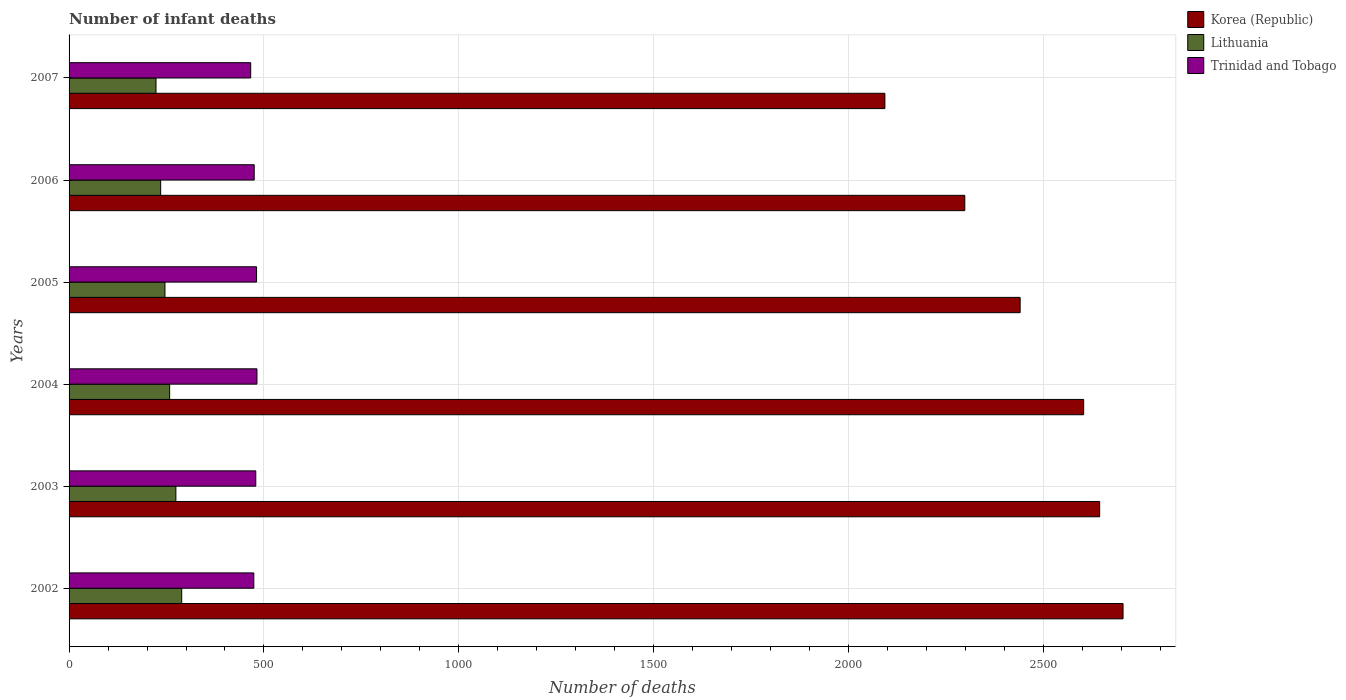How many groups of bars are there?
Your answer should be compact. 6. Are the number of bars on each tick of the Y-axis equal?
Ensure brevity in your answer.  Yes. How many bars are there on the 5th tick from the bottom?
Offer a very short reply. 3. In how many cases, is the number of bars for a given year not equal to the number of legend labels?
Offer a terse response. 0. What is the number of infant deaths in Lithuania in 2002?
Your answer should be compact. 289. Across all years, what is the maximum number of infant deaths in Trinidad and Tobago?
Offer a very short reply. 482. Across all years, what is the minimum number of infant deaths in Korea (Republic)?
Your answer should be very brief. 2093. What is the total number of infant deaths in Lithuania in the graph?
Your answer should be compact. 1525. What is the difference between the number of infant deaths in Lithuania in 2002 and that in 2005?
Give a very brief answer. 43. What is the difference between the number of infant deaths in Korea (Republic) in 2006 and the number of infant deaths in Trinidad and Tobago in 2002?
Ensure brevity in your answer.  1824. What is the average number of infant deaths in Trinidad and Tobago per year?
Provide a short and direct response. 476.17. In the year 2003, what is the difference between the number of infant deaths in Lithuania and number of infant deaths in Trinidad and Tobago?
Ensure brevity in your answer.  -205. In how many years, is the number of infant deaths in Trinidad and Tobago greater than 100 ?
Give a very brief answer. 6. What is the ratio of the number of infant deaths in Korea (Republic) in 2002 to that in 2004?
Make the answer very short. 1.04. What is the difference between the highest and the lowest number of infant deaths in Korea (Republic)?
Keep it short and to the point. 611. In how many years, is the number of infant deaths in Trinidad and Tobago greater than the average number of infant deaths in Trinidad and Tobago taken over all years?
Give a very brief answer. 3. What does the 2nd bar from the bottom in 2006 represents?
Your answer should be very brief. Lithuania. Is it the case that in every year, the sum of the number of infant deaths in Lithuania and number of infant deaths in Korea (Republic) is greater than the number of infant deaths in Trinidad and Tobago?
Provide a short and direct response. Yes. How many bars are there?
Provide a short and direct response. 18. Are all the bars in the graph horizontal?
Make the answer very short. Yes. What is the difference between two consecutive major ticks on the X-axis?
Provide a succinct answer. 500. Does the graph contain any zero values?
Offer a very short reply. No. How are the legend labels stacked?
Ensure brevity in your answer.  Vertical. What is the title of the graph?
Offer a terse response. Number of infant deaths. What is the label or title of the X-axis?
Your answer should be compact. Number of deaths. What is the Number of deaths of Korea (Republic) in 2002?
Provide a short and direct response. 2704. What is the Number of deaths in Lithuania in 2002?
Your response must be concise. 289. What is the Number of deaths of Trinidad and Tobago in 2002?
Keep it short and to the point. 474. What is the Number of deaths of Korea (Republic) in 2003?
Offer a very short reply. 2644. What is the Number of deaths of Lithuania in 2003?
Offer a terse response. 274. What is the Number of deaths in Trinidad and Tobago in 2003?
Ensure brevity in your answer.  479. What is the Number of deaths in Korea (Republic) in 2004?
Your answer should be compact. 2603. What is the Number of deaths of Lithuania in 2004?
Keep it short and to the point. 258. What is the Number of deaths in Trinidad and Tobago in 2004?
Your answer should be compact. 482. What is the Number of deaths in Korea (Republic) in 2005?
Make the answer very short. 2440. What is the Number of deaths of Lithuania in 2005?
Offer a terse response. 246. What is the Number of deaths in Trinidad and Tobago in 2005?
Offer a terse response. 481. What is the Number of deaths of Korea (Republic) in 2006?
Make the answer very short. 2298. What is the Number of deaths of Lithuania in 2006?
Provide a short and direct response. 235. What is the Number of deaths of Trinidad and Tobago in 2006?
Offer a terse response. 475. What is the Number of deaths in Korea (Republic) in 2007?
Provide a succinct answer. 2093. What is the Number of deaths in Lithuania in 2007?
Give a very brief answer. 223. What is the Number of deaths of Trinidad and Tobago in 2007?
Provide a short and direct response. 466. Across all years, what is the maximum Number of deaths in Korea (Republic)?
Make the answer very short. 2704. Across all years, what is the maximum Number of deaths of Lithuania?
Make the answer very short. 289. Across all years, what is the maximum Number of deaths of Trinidad and Tobago?
Offer a very short reply. 482. Across all years, what is the minimum Number of deaths in Korea (Republic)?
Your answer should be compact. 2093. Across all years, what is the minimum Number of deaths of Lithuania?
Your response must be concise. 223. Across all years, what is the minimum Number of deaths of Trinidad and Tobago?
Your response must be concise. 466. What is the total Number of deaths of Korea (Republic) in the graph?
Your answer should be compact. 1.48e+04. What is the total Number of deaths in Lithuania in the graph?
Your answer should be very brief. 1525. What is the total Number of deaths in Trinidad and Tobago in the graph?
Ensure brevity in your answer.  2857. What is the difference between the Number of deaths in Korea (Republic) in 2002 and that in 2003?
Ensure brevity in your answer.  60. What is the difference between the Number of deaths of Korea (Republic) in 2002 and that in 2004?
Offer a terse response. 101. What is the difference between the Number of deaths of Trinidad and Tobago in 2002 and that in 2004?
Offer a very short reply. -8. What is the difference between the Number of deaths of Korea (Republic) in 2002 and that in 2005?
Your response must be concise. 264. What is the difference between the Number of deaths of Lithuania in 2002 and that in 2005?
Give a very brief answer. 43. What is the difference between the Number of deaths in Trinidad and Tobago in 2002 and that in 2005?
Your response must be concise. -7. What is the difference between the Number of deaths of Korea (Republic) in 2002 and that in 2006?
Provide a succinct answer. 406. What is the difference between the Number of deaths of Lithuania in 2002 and that in 2006?
Ensure brevity in your answer.  54. What is the difference between the Number of deaths in Trinidad and Tobago in 2002 and that in 2006?
Your answer should be compact. -1. What is the difference between the Number of deaths in Korea (Republic) in 2002 and that in 2007?
Your response must be concise. 611. What is the difference between the Number of deaths of Lithuania in 2002 and that in 2007?
Offer a terse response. 66. What is the difference between the Number of deaths in Trinidad and Tobago in 2002 and that in 2007?
Your answer should be compact. 8. What is the difference between the Number of deaths of Lithuania in 2003 and that in 2004?
Offer a terse response. 16. What is the difference between the Number of deaths in Trinidad and Tobago in 2003 and that in 2004?
Your answer should be compact. -3. What is the difference between the Number of deaths in Korea (Republic) in 2003 and that in 2005?
Your response must be concise. 204. What is the difference between the Number of deaths of Lithuania in 2003 and that in 2005?
Offer a very short reply. 28. What is the difference between the Number of deaths of Trinidad and Tobago in 2003 and that in 2005?
Provide a succinct answer. -2. What is the difference between the Number of deaths in Korea (Republic) in 2003 and that in 2006?
Make the answer very short. 346. What is the difference between the Number of deaths in Lithuania in 2003 and that in 2006?
Make the answer very short. 39. What is the difference between the Number of deaths of Korea (Republic) in 2003 and that in 2007?
Offer a terse response. 551. What is the difference between the Number of deaths of Trinidad and Tobago in 2003 and that in 2007?
Keep it short and to the point. 13. What is the difference between the Number of deaths in Korea (Republic) in 2004 and that in 2005?
Ensure brevity in your answer.  163. What is the difference between the Number of deaths of Lithuania in 2004 and that in 2005?
Your answer should be very brief. 12. What is the difference between the Number of deaths of Trinidad and Tobago in 2004 and that in 2005?
Keep it short and to the point. 1. What is the difference between the Number of deaths of Korea (Republic) in 2004 and that in 2006?
Your answer should be very brief. 305. What is the difference between the Number of deaths in Korea (Republic) in 2004 and that in 2007?
Keep it short and to the point. 510. What is the difference between the Number of deaths of Lithuania in 2004 and that in 2007?
Ensure brevity in your answer.  35. What is the difference between the Number of deaths in Korea (Republic) in 2005 and that in 2006?
Provide a succinct answer. 142. What is the difference between the Number of deaths of Trinidad and Tobago in 2005 and that in 2006?
Offer a terse response. 6. What is the difference between the Number of deaths in Korea (Republic) in 2005 and that in 2007?
Give a very brief answer. 347. What is the difference between the Number of deaths in Lithuania in 2005 and that in 2007?
Keep it short and to the point. 23. What is the difference between the Number of deaths of Korea (Republic) in 2006 and that in 2007?
Your response must be concise. 205. What is the difference between the Number of deaths in Korea (Republic) in 2002 and the Number of deaths in Lithuania in 2003?
Make the answer very short. 2430. What is the difference between the Number of deaths in Korea (Republic) in 2002 and the Number of deaths in Trinidad and Tobago in 2003?
Keep it short and to the point. 2225. What is the difference between the Number of deaths of Lithuania in 2002 and the Number of deaths of Trinidad and Tobago in 2003?
Provide a short and direct response. -190. What is the difference between the Number of deaths in Korea (Republic) in 2002 and the Number of deaths in Lithuania in 2004?
Provide a short and direct response. 2446. What is the difference between the Number of deaths of Korea (Republic) in 2002 and the Number of deaths of Trinidad and Tobago in 2004?
Offer a terse response. 2222. What is the difference between the Number of deaths in Lithuania in 2002 and the Number of deaths in Trinidad and Tobago in 2004?
Offer a terse response. -193. What is the difference between the Number of deaths in Korea (Republic) in 2002 and the Number of deaths in Lithuania in 2005?
Your answer should be very brief. 2458. What is the difference between the Number of deaths of Korea (Republic) in 2002 and the Number of deaths of Trinidad and Tobago in 2005?
Your answer should be compact. 2223. What is the difference between the Number of deaths of Lithuania in 2002 and the Number of deaths of Trinidad and Tobago in 2005?
Your response must be concise. -192. What is the difference between the Number of deaths in Korea (Republic) in 2002 and the Number of deaths in Lithuania in 2006?
Ensure brevity in your answer.  2469. What is the difference between the Number of deaths of Korea (Republic) in 2002 and the Number of deaths of Trinidad and Tobago in 2006?
Give a very brief answer. 2229. What is the difference between the Number of deaths of Lithuania in 2002 and the Number of deaths of Trinidad and Tobago in 2006?
Give a very brief answer. -186. What is the difference between the Number of deaths in Korea (Republic) in 2002 and the Number of deaths in Lithuania in 2007?
Your response must be concise. 2481. What is the difference between the Number of deaths in Korea (Republic) in 2002 and the Number of deaths in Trinidad and Tobago in 2007?
Make the answer very short. 2238. What is the difference between the Number of deaths of Lithuania in 2002 and the Number of deaths of Trinidad and Tobago in 2007?
Make the answer very short. -177. What is the difference between the Number of deaths in Korea (Republic) in 2003 and the Number of deaths in Lithuania in 2004?
Offer a terse response. 2386. What is the difference between the Number of deaths in Korea (Republic) in 2003 and the Number of deaths in Trinidad and Tobago in 2004?
Give a very brief answer. 2162. What is the difference between the Number of deaths of Lithuania in 2003 and the Number of deaths of Trinidad and Tobago in 2004?
Your answer should be compact. -208. What is the difference between the Number of deaths of Korea (Republic) in 2003 and the Number of deaths of Lithuania in 2005?
Provide a short and direct response. 2398. What is the difference between the Number of deaths in Korea (Republic) in 2003 and the Number of deaths in Trinidad and Tobago in 2005?
Keep it short and to the point. 2163. What is the difference between the Number of deaths in Lithuania in 2003 and the Number of deaths in Trinidad and Tobago in 2005?
Give a very brief answer. -207. What is the difference between the Number of deaths in Korea (Republic) in 2003 and the Number of deaths in Lithuania in 2006?
Offer a very short reply. 2409. What is the difference between the Number of deaths of Korea (Republic) in 2003 and the Number of deaths of Trinidad and Tobago in 2006?
Offer a terse response. 2169. What is the difference between the Number of deaths of Lithuania in 2003 and the Number of deaths of Trinidad and Tobago in 2006?
Keep it short and to the point. -201. What is the difference between the Number of deaths in Korea (Republic) in 2003 and the Number of deaths in Lithuania in 2007?
Your answer should be compact. 2421. What is the difference between the Number of deaths of Korea (Republic) in 2003 and the Number of deaths of Trinidad and Tobago in 2007?
Offer a very short reply. 2178. What is the difference between the Number of deaths in Lithuania in 2003 and the Number of deaths in Trinidad and Tobago in 2007?
Offer a very short reply. -192. What is the difference between the Number of deaths of Korea (Republic) in 2004 and the Number of deaths of Lithuania in 2005?
Keep it short and to the point. 2357. What is the difference between the Number of deaths in Korea (Republic) in 2004 and the Number of deaths in Trinidad and Tobago in 2005?
Your response must be concise. 2122. What is the difference between the Number of deaths in Lithuania in 2004 and the Number of deaths in Trinidad and Tobago in 2005?
Offer a very short reply. -223. What is the difference between the Number of deaths of Korea (Republic) in 2004 and the Number of deaths of Lithuania in 2006?
Your response must be concise. 2368. What is the difference between the Number of deaths of Korea (Republic) in 2004 and the Number of deaths of Trinidad and Tobago in 2006?
Your response must be concise. 2128. What is the difference between the Number of deaths in Lithuania in 2004 and the Number of deaths in Trinidad and Tobago in 2006?
Give a very brief answer. -217. What is the difference between the Number of deaths in Korea (Republic) in 2004 and the Number of deaths in Lithuania in 2007?
Provide a short and direct response. 2380. What is the difference between the Number of deaths in Korea (Republic) in 2004 and the Number of deaths in Trinidad and Tobago in 2007?
Offer a very short reply. 2137. What is the difference between the Number of deaths of Lithuania in 2004 and the Number of deaths of Trinidad and Tobago in 2007?
Provide a short and direct response. -208. What is the difference between the Number of deaths in Korea (Republic) in 2005 and the Number of deaths in Lithuania in 2006?
Provide a short and direct response. 2205. What is the difference between the Number of deaths in Korea (Republic) in 2005 and the Number of deaths in Trinidad and Tobago in 2006?
Ensure brevity in your answer.  1965. What is the difference between the Number of deaths of Lithuania in 2005 and the Number of deaths of Trinidad and Tobago in 2006?
Offer a very short reply. -229. What is the difference between the Number of deaths of Korea (Republic) in 2005 and the Number of deaths of Lithuania in 2007?
Your answer should be compact. 2217. What is the difference between the Number of deaths in Korea (Republic) in 2005 and the Number of deaths in Trinidad and Tobago in 2007?
Your response must be concise. 1974. What is the difference between the Number of deaths of Lithuania in 2005 and the Number of deaths of Trinidad and Tobago in 2007?
Keep it short and to the point. -220. What is the difference between the Number of deaths of Korea (Republic) in 2006 and the Number of deaths of Lithuania in 2007?
Make the answer very short. 2075. What is the difference between the Number of deaths of Korea (Republic) in 2006 and the Number of deaths of Trinidad and Tobago in 2007?
Offer a very short reply. 1832. What is the difference between the Number of deaths of Lithuania in 2006 and the Number of deaths of Trinidad and Tobago in 2007?
Offer a very short reply. -231. What is the average Number of deaths of Korea (Republic) per year?
Give a very brief answer. 2463.67. What is the average Number of deaths in Lithuania per year?
Give a very brief answer. 254.17. What is the average Number of deaths in Trinidad and Tobago per year?
Make the answer very short. 476.17. In the year 2002, what is the difference between the Number of deaths of Korea (Republic) and Number of deaths of Lithuania?
Make the answer very short. 2415. In the year 2002, what is the difference between the Number of deaths in Korea (Republic) and Number of deaths in Trinidad and Tobago?
Your answer should be compact. 2230. In the year 2002, what is the difference between the Number of deaths of Lithuania and Number of deaths of Trinidad and Tobago?
Give a very brief answer. -185. In the year 2003, what is the difference between the Number of deaths in Korea (Republic) and Number of deaths in Lithuania?
Your answer should be compact. 2370. In the year 2003, what is the difference between the Number of deaths of Korea (Republic) and Number of deaths of Trinidad and Tobago?
Offer a very short reply. 2165. In the year 2003, what is the difference between the Number of deaths of Lithuania and Number of deaths of Trinidad and Tobago?
Offer a very short reply. -205. In the year 2004, what is the difference between the Number of deaths in Korea (Republic) and Number of deaths in Lithuania?
Ensure brevity in your answer.  2345. In the year 2004, what is the difference between the Number of deaths in Korea (Republic) and Number of deaths in Trinidad and Tobago?
Keep it short and to the point. 2121. In the year 2004, what is the difference between the Number of deaths of Lithuania and Number of deaths of Trinidad and Tobago?
Give a very brief answer. -224. In the year 2005, what is the difference between the Number of deaths in Korea (Republic) and Number of deaths in Lithuania?
Make the answer very short. 2194. In the year 2005, what is the difference between the Number of deaths of Korea (Republic) and Number of deaths of Trinidad and Tobago?
Ensure brevity in your answer.  1959. In the year 2005, what is the difference between the Number of deaths in Lithuania and Number of deaths in Trinidad and Tobago?
Your response must be concise. -235. In the year 2006, what is the difference between the Number of deaths in Korea (Republic) and Number of deaths in Lithuania?
Provide a succinct answer. 2063. In the year 2006, what is the difference between the Number of deaths in Korea (Republic) and Number of deaths in Trinidad and Tobago?
Offer a terse response. 1823. In the year 2006, what is the difference between the Number of deaths of Lithuania and Number of deaths of Trinidad and Tobago?
Give a very brief answer. -240. In the year 2007, what is the difference between the Number of deaths of Korea (Republic) and Number of deaths of Lithuania?
Your response must be concise. 1870. In the year 2007, what is the difference between the Number of deaths of Korea (Republic) and Number of deaths of Trinidad and Tobago?
Make the answer very short. 1627. In the year 2007, what is the difference between the Number of deaths in Lithuania and Number of deaths in Trinidad and Tobago?
Give a very brief answer. -243. What is the ratio of the Number of deaths in Korea (Republic) in 2002 to that in 2003?
Your answer should be very brief. 1.02. What is the ratio of the Number of deaths of Lithuania in 2002 to that in 2003?
Your answer should be very brief. 1.05. What is the ratio of the Number of deaths in Trinidad and Tobago in 2002 to that in 2003?
Provide a short and direct response. 0.99. What is the ratio of the Number of deaths of Korea (Republic) in 2002 to that in 2004?
Make the answer very short. 1.04. What is the ratio of the Number of deaths in Lithuania in 2002 to that in 2004?
Make the answer very short. 1.12. What is the ratio of the Number of deaths in Trinidad and Tobago in 2002 to that in 2004?
Ensure brevity in your answer.  0.98. What is the ratio of the Number of deaths of Korea (Republic) in 2002 to that in 2005?
Provide a short and direct response. 1.11. What is the ratio of the Number of deaths of Lithuania in 2002 to that in 2005?
Provide a succinct answer. 1.17. What is the ratio of the Number of deaths of Trinidad and Tobago in 2002 to that in 2005?
Keep it short and to the point. 0.99. What is the ratio of the Number of deaths in Korea (Republic) in 2002 to that in 2006?
Offer a terse response. 1.18. What is the ratio of the Number of deaths in Lithuania in 2002 to that in 2006?
Your answer should be very brief. 1.23. What is the ratio of the Number of deaths in Korea (Republic) in 2002 to that in 2007?
Provide a short and direct response. 1.29. What is the ratio of the Number of deaths in Lithuania in 2002 to that in 2007?
Ensure brevity in your answer.  1.3. What is the ratio of the Number of deaths in Trinidad and Tobago in 2002 to that in 2007?
Provide a short and direct response. 1.02. What is the ratio of the Number of deaths of Korea (Republic) in 2003 to that in 2004?
Offer a terse response. 1.02. What is the ratio of the Number of deaths in Lithuania in 2003 to that in 2004?
Your answer should be very brief. 1.06. What is the ratio of the Number of deaths in Trinidad and Tobago in 2003 to that in 2004?
Provide a short and direct response. 0.99. What is the ratio of the Number of deaths of Korea (Republic) in 2003 to that in 2005?
Offer a terse response. 1.08. What is the ratio of the Number of deaths of Lithuania in 2003 to that in 2005?
Keep it short and to the point. 1.11. What is the ratio of the Number of deaths in Korea (Republic) in 2003 to that in 2006?
Provide a short and direct response. 1.15. What is the ratio of the Number of deaths of Lithuania in 2003 to that in 2006?
Offer a very short reply. 1.17. What is the ratio of the Number of deaths in Trinidad and Tobago in 2003 to that in 2006?
Offer a very short reply. 1.01. What is the ratio of the Number of deaths of Korea (Republic) in 2003 to that in 2007?
Keep it short and to the point. 1.26. What is the ratio of the Number of deaths of Lithuania in 2003 to that in 2007?
Your response must be concise. 1.23. What is the ratio of the Number of deaths of Trinidad and Tobago in 2003 to that in 2007?
Ensure brevity in your answer.  1.03. What is the ratio of the Number of deaths of Korea (Republic) in 2004 to that in 2005?
Your response must be concise. 1.07. What is the ratio of the Number of deaths in Lithuania in 2004 to that in 2005?
Keep it short and to the point. 1.05. What is the ratio of the Number of deaths of Korea (Republic) in 2004 to that in 2006?
Your answer should be very brief. 1.13. What is the ratio of the Number of deaths of Lithuania in 2004 to that in 2006?
Provide a short and direct response. 1.1. What is the ratio of the Number of deaths in Trinidad and Tobago in 2004 to that in 2006?
Provide a short and direct response. 1.01. What is the ratio of the Number of deaths in Korea (Republic) in 2004 to that in 2007?
Provide a succinct answer. 1.24. What is the ratio of the Number of deaths in Lithuania in 2004 to that in 2007?
Provide a short and direct response. 1.16. What is the ratio of the Number of deaths of Trinidad and Tobago in 2004 to that in 2007?
Give a very brief answer. 1.03. What is the ratio of the Number of deaths in Korea (Republic) in 2005 to that in 2006?
Ensure brevity in your answer.  1.06. What is the ratio of the Number of deaths in Lithuania in 2005 to that in 2006?
Keep it short and to the point. 1.05. What is the ratio of the Number of deaths of Trinidad and Tobago in 2005 to that in 2006?
Offer a terse response. 1.01. What is the ratio of the Number of deaths of Korea (Republic) in 2005 to that in 2007?
Ensure brevity in your answer.  1.17. What is the ratio of the Number of deaths in Lithuania in 2005 to that in 2007?
Keep it short and to the point. 1.1. What is the ratio of the Number of deaths in Trinidad and Tobago in 2005 to that in 2007?
Keep it short and to the point. 1.03. What is the ratio of the Number of deaths in Korea (Republic) in 2006 to that in 2007?
Make the answer very short. 1.1. What is the ratio of the Number of deaths of Lithuania in 2006 to that in 2007?
Give a very brief answer. 1.05. What is the ratio of the Number of deaths of Trinidad and Tobago in 2006 to that in 2007?
Your answer should be very brief. 1.02. What is the difference between the highest and the lowest Number of deaths of Korea (Republic)?
Give a very brief answer. 611. What is the difference between the highest and the lowest Number of deaths of Trinidad and Tobago?
Ensure brevity in your answer.  16. 